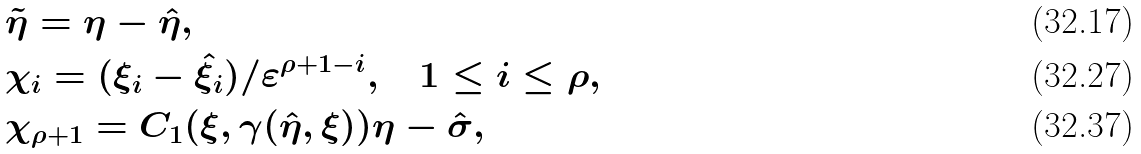Convert formula to latex. <formula><loc_0><loc_0><loc_500><loc_500>& \tilde { \eta } = \eta - \hat { \eta } , \\ & \chi _ { i } = ( \xi _ { i } - \hat { \xi } _ { i } ) / \varepsilon ^ { \rho + 1 - i } , \quad 1 \leq i \leq \rho , \\ & \chi _ { \rho + 1 } = C _ { 1 } ( \xi , \gamma ( \hat { \eta } , \xi ) ) \eta - \hat { \sigma } ,</formula> 